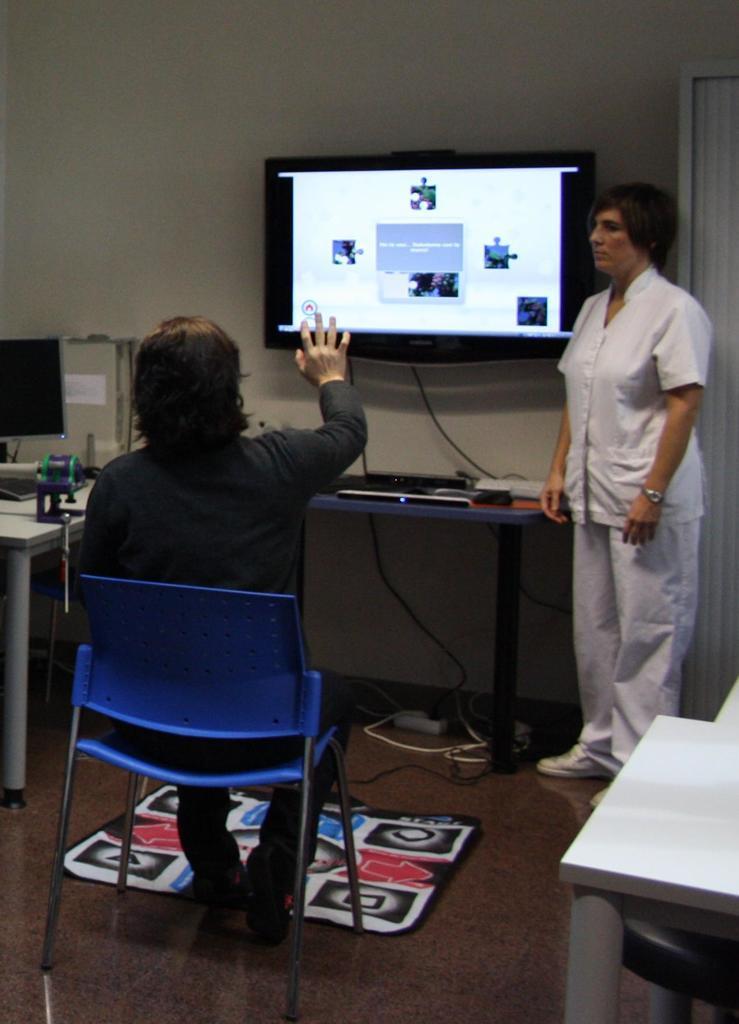Could you give a brief overview of what you see in this image? A picture inside of a room. A screen is attached to the wall. On this table there are things. This man is sitting on a blue chair. This woman is standing and wore white shirt. On floor there are cables. On this table there is a monitor. 